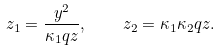<formula> <loc_0><loc_0><loc_500><loc_500>z _ { 1 } = \frac { y ^ { 2 } } { \kappa _ { 1 } q z } , \quad z _ { 2 } = \kappa _ { 1 } \kappa _ { 2 } q z .</formula> 